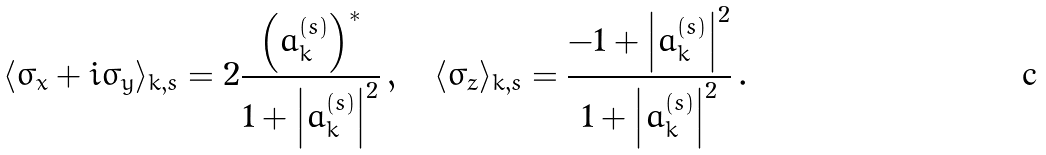Convert formula to latex. <formula><loc_0><loc_0><loc_500><loc_500>\langle \sigma _ { x } + i \sigma _ { y } \rangle _ { k , s } = 2 \frac { \left ( a _ { k } ^ { ( s ) } \right ) ^ { * } } { 1 + \left | a _ { k } ^ { ( s ) } \right | ^ { 2 } } \, , \quad \langle \sigma _ { z } \rangle _ { k , s } = \frac { - 1 + \left | a _ { k } ^ { ( s ) } \right | ^ { 2 } } { 1 + \left | a _ { k } ^ { ( s ) } \right | ^ { 2 } } \, .</formula> 